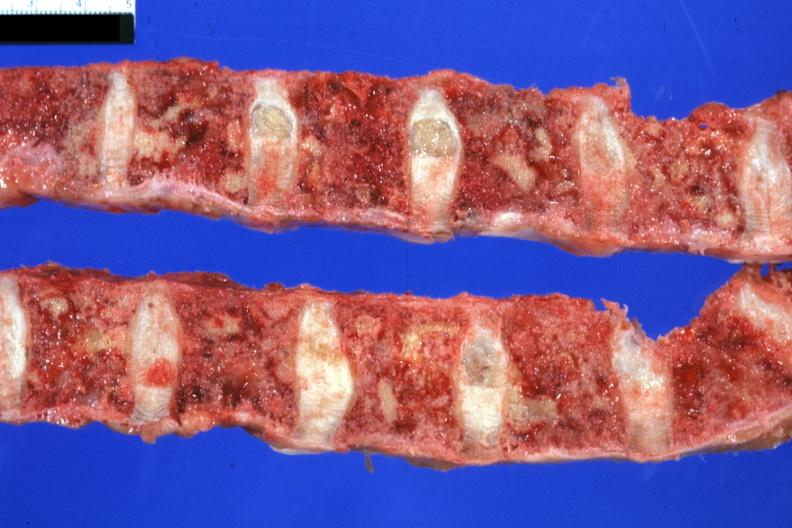how does this image show vertebral column?
Answer the question using a single word or phrase. With multiple lesions easily seen colon primary 